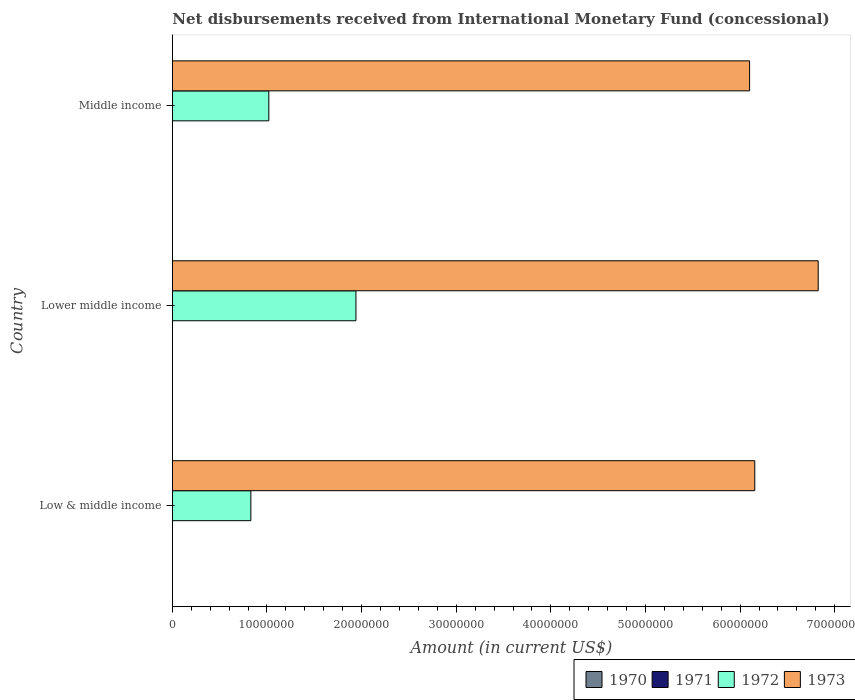How many different coloured bars are there?
Ensure brevity in your answer.  2. How many bars are there on the 1st tick from the top?
Give a very brief answer. 2. What is the label of the 1st group of bars from the top?
Ensure brevity in your answer.  Middle income. Across all countries, what is the maximum amount of disbursements received from International Monetary Fund in 1972?
Give a very brief answer. 1.94e+07. In which country was the amount of disbursements received from International Monetary Fund in 1972 maximum?
Offer a terse response. Lower middle income. What is the total amount of disbursements received from International Monetary Fund in 1972 in the graph?
Give a very brief answer. 3.79e+07. What is the difference between the amount of disbursements received from International Monetary Fund in 1973 in Lower middle income and that in Middle income?
Keep it short and to the point. 7.25e+06. What is the difference between the amount of disbursements received from International Monetary Fund in 1970 in Lower middle income and the amount of disbursements received from International Monetary Fund in 1973 in Low & middle income?
Offer a terse response. -6.16e+07. What is the average amount of disbursements received from International Monetary Fund in 1970 per country?
Keep it short and to the point. 0. What is the difference between the amount of disbursements received from International Monetary Fund in 1973 and amount of disbursements received from International Monetary Fund in 1972 in Lower middle income?
Your answer should be compact. 4.89e+07. In how many countries, is the amount of disbursements received from International Monetary Fund in 1971 greater than 36000000 US$?
Your answer should be very brief. 0. What is the ratio of the amount of disbursements received from International Monetary Fund in 1972 in Low & middle income to that in Middle income?
Offer a very short reply. 0.81. What is the difference between the highest and the second highest amount of disbursements received from International Monetary Fund in 1973?
Your answer should be very brief. 6.70e+06. What is the difference between the highest and the lowest amount of disbursements received from International Monetary Fund in 1973?
Provide a succinct answer. 7.25e+06. Is it the case that in every country, the sum of the amount of disbursements received from International Monetary Fund in 1972 and amount of disbursements received from International Monetary Fund in 1971 is greater than the sum of amount of disbursements received from International Monetary Fund in 1970 and amount of disbursements received from International Monetary Fund in 1973?
Give a very brief answer. No. Is it the case that in every country, the sum of the amount of disbursements received from International Monetary Fund in 1970 and amount of disbursements received from International Monetary Fund in 1972 is greater than the amount of disbursements received from International Monetary Fund in 1973?
Make the answer very short. No. How many countries are there in the graph?
Make the answer very short. 3. Does the graph contain any zero values?
Keep it short and to the point. Yes. Does the graph contain grids?
Ensure brevity in your answer.  No. How many legend labels are there?
Your answer should be compact. 4. How are the legend labels stacked?
Provide a succinct answer. Horizontal. What is the title of the graph?
Make the answer very short. Net disbursements received from International Monetary Fund (concessional). Does "1985" appear as one of the legend labels in the graph?
Offer a very short reply. No. What is the Amount (in current US$) of 1971 in Low & middle income?
Give a very brief answer. 0. What is the Amount (in current US$) in 1972 in Low & middle income?
Provide a short and direct response. 8.30e+06. What is the Amount (in current US$) of 1973 in Low & middle income?
Ensure brevity in your answer.  6.16e+07. What is the Amount (in current US$) of 1970 in Lower middle income?
Provide a short and direct response. 0. What is the Amount (in current US$) in 1972 in Lower middle income?
Provide a short and direct response. 1.94e+07. What is the Amount (in current US$) in 1973 in Lower middle income?
Offer a very short reply. 6.83e+07. What is the Amount (in current US$) of 1970 in Middle income?
Your answer should be very brief. 0. What is the Amount (in current US$) of 1972 in Middle income?
Give a very brief answer. 1.02e+07. What is the Amount (in current US$) of 1973 in Middle income?
Provide a short and direct response. 6.10e+07. Across all countries, what is the maximum Amount (in current US$) of 1972?
Offer a very short reply. 1.94e+07. Across all countries, what is the maximum Amount (in current US$) of 1973?
Ensure brevity in your answer.  6.83e+07. Across all countries, what is the minimum Amount (in current US$) of 1972?
Your answer should be very brief. 8.30e+06. Across all countries, what is the minimum Amount (in current US$) in 1973?
Offer a terse response. 6.10e+07. What is the total Amount (in current US$) in 1970 in the graph?
Make the answer very short. 0. What is the total Amount (in current US$) in 1971 in the graph?
Offer a very short reply. 0. What is the total Amount (in current US$) in 1972 in the graph?
Your answer should be very brief. 3.79e+07. What is the total Amount (in current US$) of 1973 in the graph?
Your answer should be compact. 1.91e+08. What is the difference between the Amount (in current US$) in 1972 in Low & middle income and that in Lower middle income?
Your answer should be compact. -1.11e+07. What is the difference between the Amount (in current US$) of 1973 in Low & middle income and that in Lower middle income?
Give a very brief answer. -6.70e+06. What is the difference between the Amount (in current US$) of 1972 in Low & middle income and that in Middle income?
Make the answer very short. -1.90e+06. What is the difference between the Amount (in current US$) of 1973 in Low & middle income and that in Middle income?
Ensure brevity in your answer.  5.46e+05. What is the difference between the Amount (in current US$) in 1972 in Lower middle income and that in Middle income?
Your answer should be very brief. 9.21e+06. What is the difference between the Amount (in current US$) in 1973 in Lower middle income and that in Middle income?
Offer a very short reply. 7.25e+06. What is the difference between the Amount (in current US$) of 1972 in Low & middle income and the Amount (in current US$) of 1973 in Lower middle income?
Keep it short and to the point. -6.00e+07. What is the difference between the Amount (in current US$) of 1972 in Low & middle income and the Amount (in current US$) of 1973 in Middle income?
Offer a very short reply. -5.27e+07. What is the difference between the Amount (in current US$) of 1972 in Lower middle income and the Amount (in current US$) of 1973 in Middle income?
Ensure brevity in your answer.  -4.16e+07. What is the average Amount (in current US$) in 1972 per country?
Your answer should be compact. 1.26e+07. What is the average Amount (in current US$) of 1973 per country?
Your answer should be very brief. 6.36e+07. What is the difference between the Amount (in current US$) of 1972 and Amount (in current US$) of 1973 in Low & middle income?
Offer a terse response. -5.33e+07. What is the difference between the Amount (in current US$) in 1972 and Amount (in current US$) in 1973 in Lower middle income?
Make the answer very short. -4.89e+07. What is the difference between the Amount (in current US$) in 1972 and Amount (in current US$) in 1973 in Middle income?
Ensure brevity in your answer.  -5.08e+07. What is the ratio of the Amount (in current US$) of 1972 in Low & middle income to that in Lower middle income?
Ensure brevity in your answer.  0.43. What is the ratio of the Amount (in current US$) in 1973 in Low & middle income to that in Lower middle income?
Keep it short and to the point. 0.9. What is the ratio of the Amount (in current US$) of 1972 in Low & middle income to that in Middle income?
Your answer should be very brief. 0.81. What is the ratio of the Amount (in current US$) of 1973 in Low & middle income to that in Middle income?
Offer a terse response. 1.01. What is the ratio of the Amount (in current US$) in 1972 in Lower middle income to that in Middle income?
Make the answer very short. 1.9. What is the ratio of the Amount (in current US$) of 1973 in Lower middle income to that in Middle income?
Ensure brevity in your answer.  1.12. What is the difference between the highest and the second highest Amount (in current US$) in 1972?
Offer a very short reply. 9.21e+06. What is the difference between the highest and the second highest Amount (in current US$) in 1973?
Keep it short and to the point. 6.70e+06. What is the difference between the highest and the lowest Amount (in current US$) in 1972?
Offer a very short reply. 1.11e+07. What is the difference between the highest and the lowest Amount (in current US$) of 1973?
Your answer should be compact. 7.25e+06. 